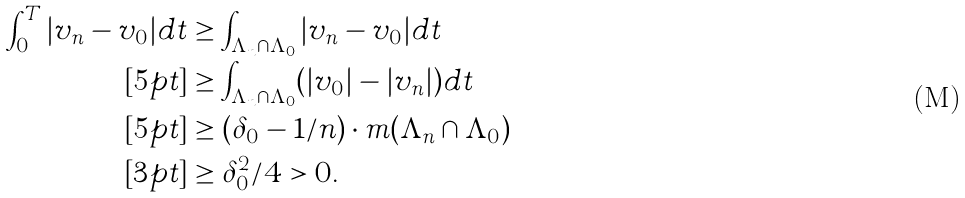<formula> <loc_0><loc_0><loc_500><loc_500>\int _ { 0 } ^ { T } | v _ { n } - v _ { 0 } | d t & \geq \int _ { \Lambda _ { n } \cap \Lambda _ { 0 } } | v _ { n } - v _ { 0 } | d t \\ [ 5 p t ] & \geq \int _ { \Lambda _ { n } \cap \Lambda _ { 0 } } ( | v _ { 0 } | - | v _ { n } | ) d t \\ [ 5 p t ] & \geq ( \delta _ { 0 } - 1 / n ) \cdot m ( \Lambda _ { n } \cap \Lambda _ { 0 } ) \\ [ 3 p t ] & \geq \delta _ { 0 } ^ { 2 } / 4 > 0 .</formula> 